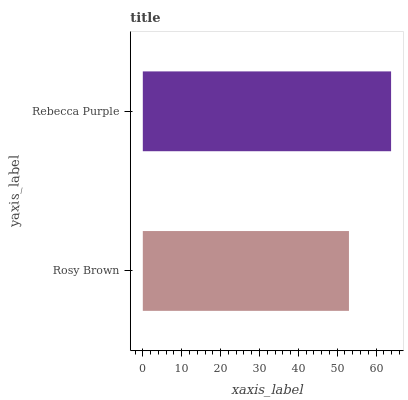Is Rosy Brown the minimum?
Answer yes or no. Yes. Is Rebecca Purple the maximum?
Answer yes or no. Yes. Is Rebecca Purple the minimum?
Answer yes or no. No. Is Rebecca Purple greater than Rosy Brown?
Answer yes or no. Yes. Is Rosy Brown less than Rebecca Purple?
Answer yes or no. Yes. Is Rosy Brown greater than Rebecca Purple?
Answer yes or no. No. Is Rebecca Purple less than Rosy Brown?
Answer yes or no. No. Is Rebecca Purple the high median?
Answer yes or no. Yes. Is Rosy Brown the low median?
Answer yes or no. Yes. Is Rosy Brown the high median?
Answer yes or no. No. Is Rebecca Purple the low median?
Answer yes or no. No. 